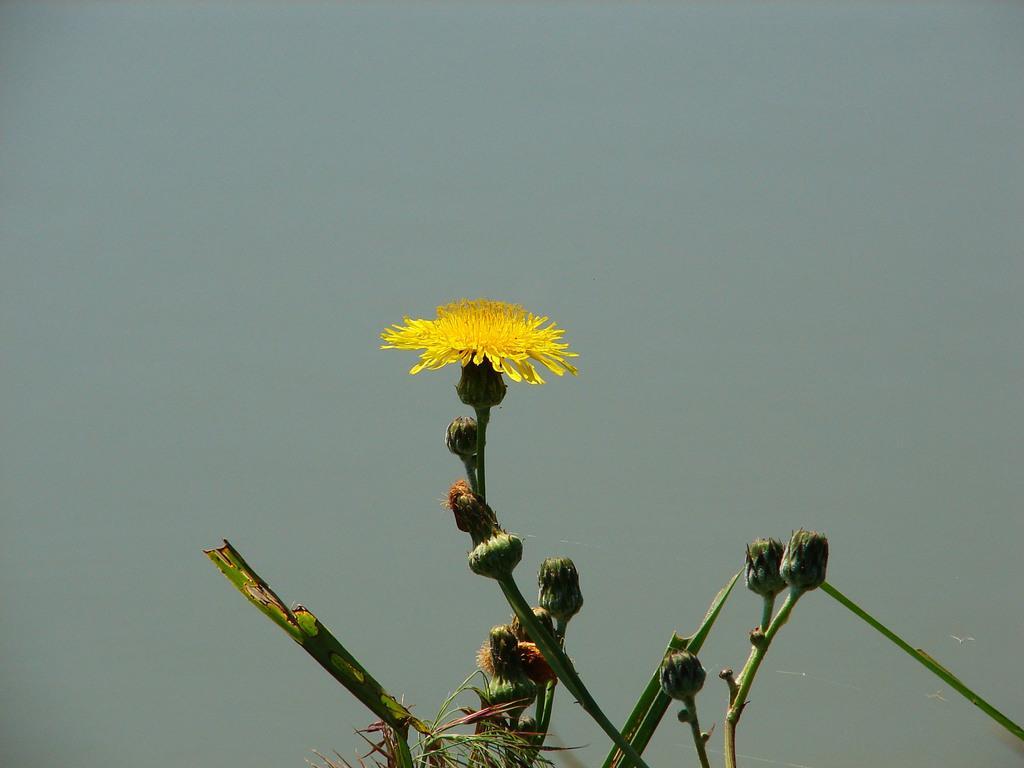How would you summarize this image in a sentence or two? In this picture I can see there is a plant where there is a flower and there are some buds to the plant and the sky is clear. 